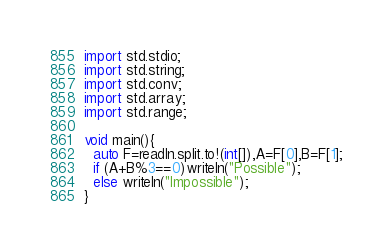Convert code to text. <code><loc_0><loc_0><loc_500><loc_500><_D_>import std.stdio;
import std.string;
import std.conv;
import std.array;
import std.range;

void main(){
  auto F=readln.split.to!(int[]),A=F[0],B=F[1];
  if (A+B%3==0)writeln("Possible");
  else writeln("Impossible");
}</code> 